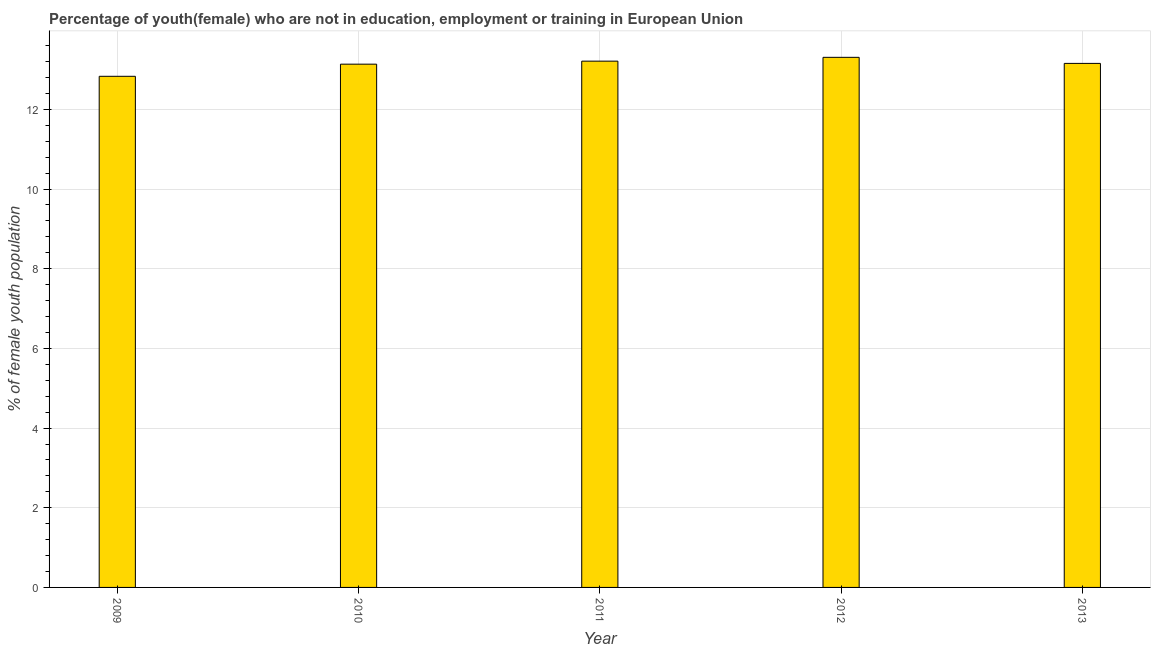What is the title of the graph?
Provide a succinct answer. Percentage of youth(female) who are not in education, employment or training in European Union. What is the label or title of the X-axis?
Offer a terse response. Year. What is the label or title of the Y-axis?
Provide a succinct answer. % of female youth population. What is the unemployed female youth population in 2013?
Your answer should be very brief. 13.15. Across all years, what is the maximum unemployed female youth population?
Offer a very short reply. 13.31. Across all years, what is the minimum unemployed female youth population?
Provide a short and direct response. 12.83. In which year was the unemployed female youth population maximum?
Make the answer very short. 2012. What is the sum of the unemployed female youth population?
Your answer should be very brief. 65.63. What is the difference between the unemployed female youth population in 2011 and 2012?
Provide a short and direct response. -0.1. What is the average unemployed female youth population per year?
Offer a terse response. 13.13. What is the median unemployed female youth population?
Offer a terse response. 13.15. What is the ratio of the unemployed female youth population in 2010 to that in 2012?
Provide a short and direct response. 0.99. Is the unemployed female youth population in 2009 less than that in 2010?
Keep it short and to the point. Yes. Is the difference between the unemployed female youth population in 2009 and 2012 greater than the difference between any two years?
Make the answer very short. Yes. What is the difference between the highest and the second highest unemployed female youth population?
Give a very brief answer. 0.1. What is the difference between the highest and the lowest unemployed female youth population?
Your answer should be compact. 0.48. In how many years, is the unemployed female youth population greater than the average unemployed female youth population taken over all years?
Provide a succinct answer. 4. How many bars are there?
Offer a terse response. 5. How many years are there in the graph?
Your response must be concise. 5. What is the difference between two consecutive major ticks on the Y-axis?
Your answer should be compact. 2. What is the % of female youth population of 2009?
Offer a terse response. 12.83. What is the % of female youth population of 2010?
Offer a terse response. 13.13. What is the % of female youth population of 2011?
Your answer should be compact. 13.21. What is the % of female youth population of 2012?
Provide a succinct answer. 13.31. What is the % of female youth population of 2013?
Your answer should be compact. 13.15. What is the difference between the % of female youth population in 2009 and 2010?
Make the answer very short. -0.3. What is the difference between the % of female youth population in 2009 and 2011?
Give a very brief answer. -0.38. What is the difference between the % of female youth population in 2009 and 2012?
Make the answer very short. -0.48. What is the difference between the % of female youth population in 2009 and 2013?
Keep it short and to the point. -0.32. What is the difference between the % of female youth population in 2010 and 2011?
Make the answer very short. -0.08. What is the difference between the % of female youth population in 2010 and 2012?
Keep it short and to the point. -0.17. What is the difference between the % of female youth population in 2010 and 2013?
Provide a short and direct response. -0.02. What is the difference between the % of female youth population in 2011 and 2012?
Your answer should be compact. -0.1. What is the difference between the % of female youth population in 2011 and 2013?
Offer a terse response. 0.06. What is the difference between the % of female youth population in 2012 and 2013?
Keep it short and to the point. 0.15. What is the ratio of the % of female youth population in 2009 to that in 2010?
Make the answer very short. 0.98. What is the ratio of the % of female youth population in 2009 to that in 2011?
Offer a very short reply. 0.97. What is the ratio of the % of female youth population in 2009 to that in 2012?
Offer a terse response. 0.96. What is the ratio of the % of female youth population in 2011 to that in 2012?
Provide a short and direct response. 0.99. What is the ratio of the % of female youth population in 2012 to that in 2013?
Offer a terse response. 1.01. 